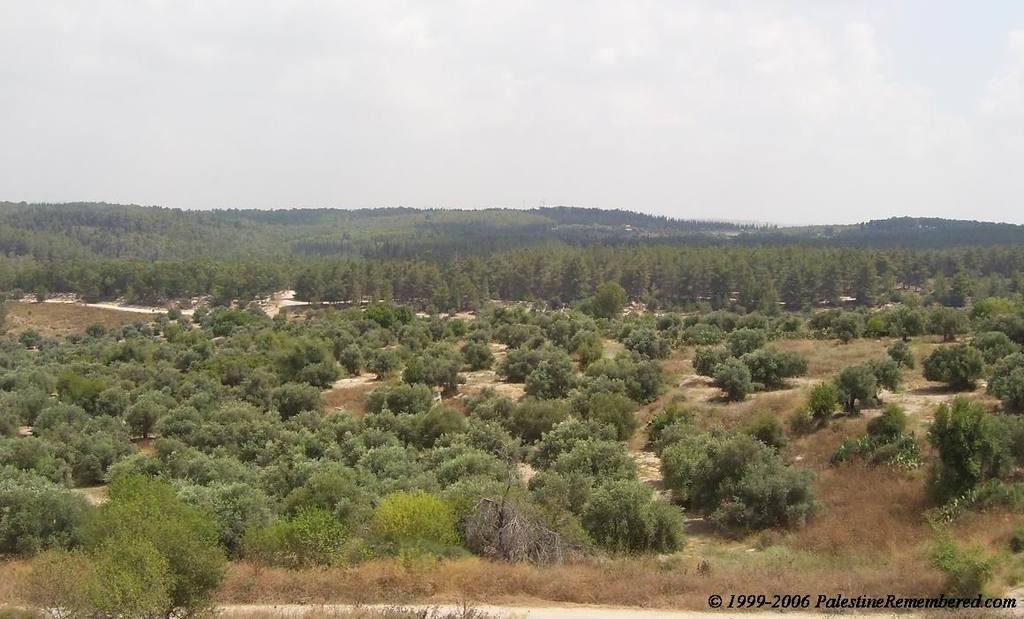What type of natural elements can be seen in the image? There are trees and hills in the image. What part of the natural environment is visible in the image? The sky is visible in the image. Can you describe the watermark on the image? The watermark is present on the image, but its specific details are not mentioned in the provided facts. What type of bait is being used by the bee in the image? There is no bee present in the image, so it is not possible to determine what type of bait might be used. 